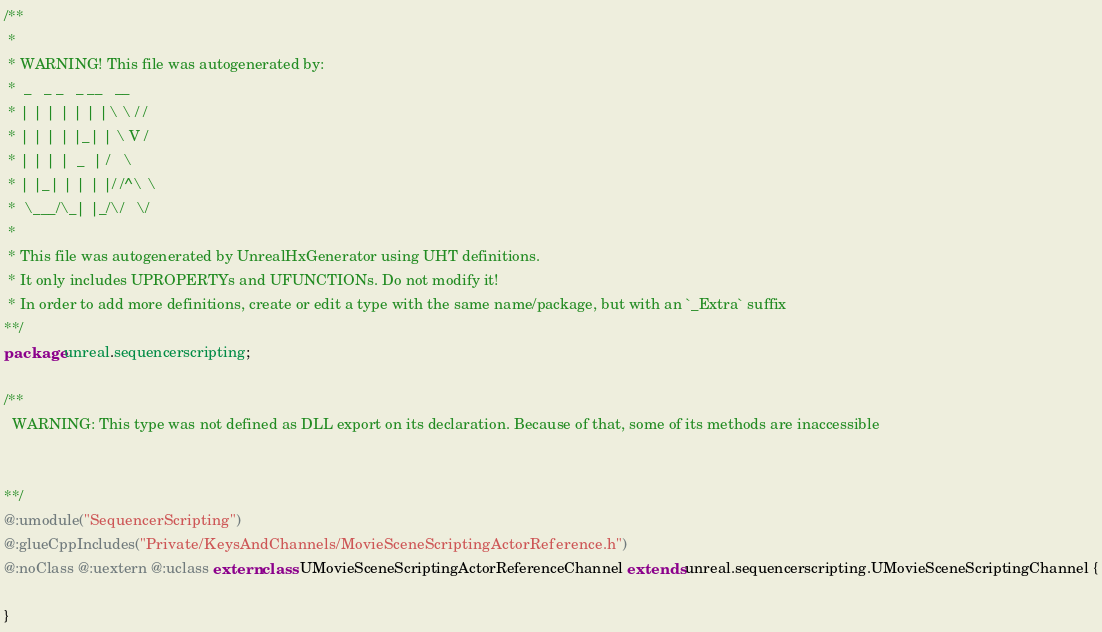Convert code to text. <code><loc_0><loc_0><loc_500><loc_500><_Haxe_>/**
 * 
 * WARNING! This file was autogenerated by: 
 *  _   _ _   _ __   __ 
 * | | | | | | |\ \ / / 
 * | | | | |_| | \ V /  
 * | | | |  _  | /   \  
 * | |_| | | | |/ /^\ \ 
 *  \___/\_| |_/\/   \/ 
 * 
 * This file was autogenerated by UnrealHxGenerator using UHT definitions.
 * It only includes UPROPERTYs and UFUNCTIONs. Do not modify it!
 * In order to add more definitions, create or edit a type with the same name/package, but with an `_Extra` suffix
**/
package unreal.sequencerscripting;

/**
  WARNING: This type was not defined as DLL export on its declaration. Because of that, some of its methods are inaccessible
  
  
**/
@:umodule("SequencerScripting")
@:glueCppIncludes("Private/KeysAndChannels/MovieSceneScriptingActorReference.h")
@:noClass @:uextern @:uclass extern class UMovieSceneScriptingActorReferenceChannel extends unreal.sequencerscripting.UMovieSceneScriptingChannel {
  
}
</code> 